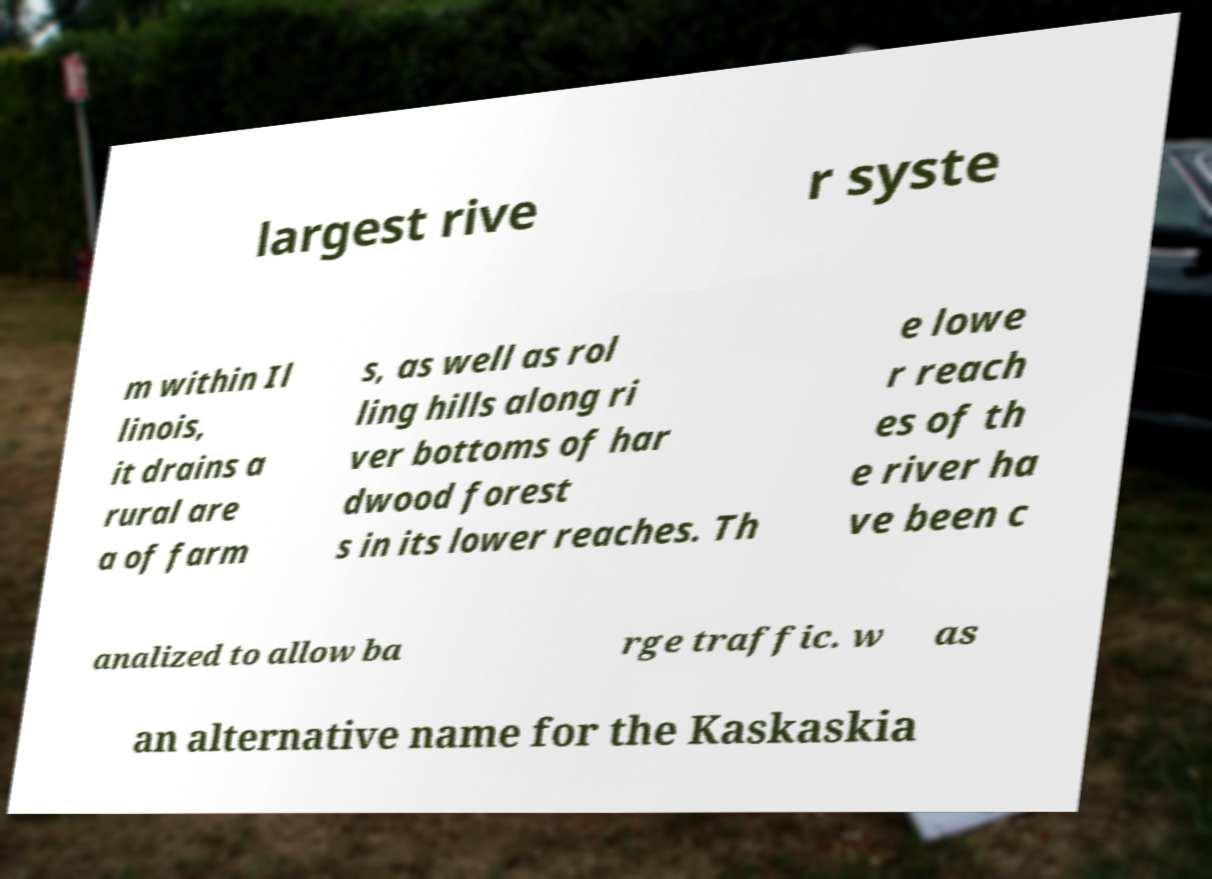There's text embedded in this image that I need extracted. Can you transcribe it verbatim? largest rive r syste m within Il linois, it drains a rural are a of farm s, as well as rol ling hills along ri ver bottoms of har dwood forest s in its lower reaches. Th e lowe r reach es of th e river ha ve been c analized to allow ba rge traffic. w as an alternative name for the Kaskaskia 